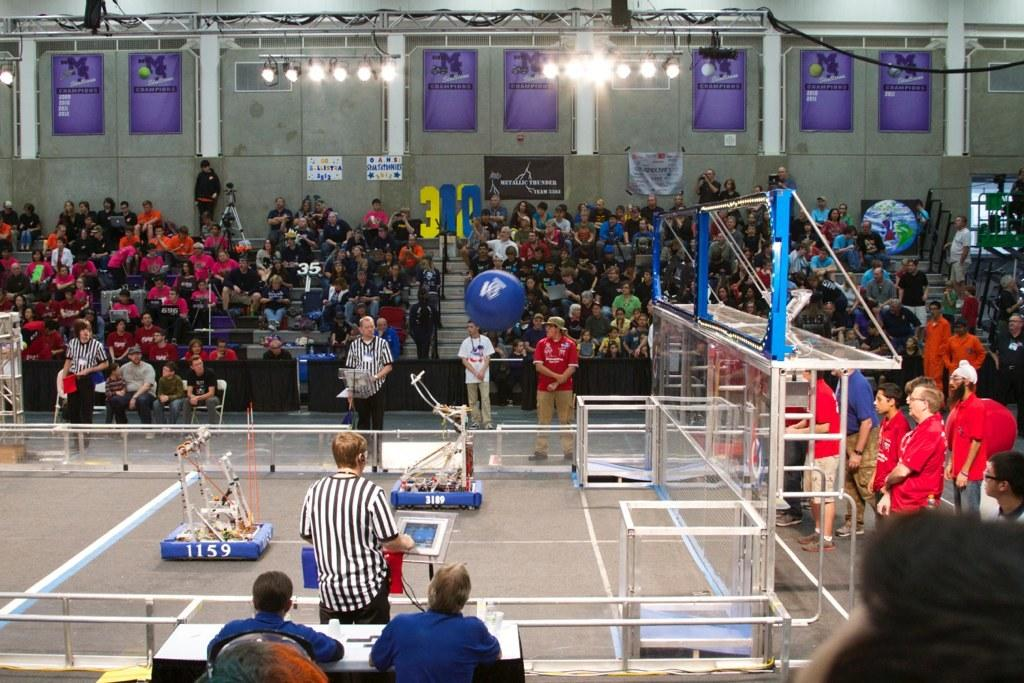What type of venue is shown in the image? The image depicts a stadium. What activity is taking place in the stadium? Players are playing a game in the stadium. Who is watching the game in the image? There is a crowd sitting around the stadium, watching the game. How many deer can be seen in the image? There are no deer present in the image; it depicts a stadium with a game being played and a crowd watching. 